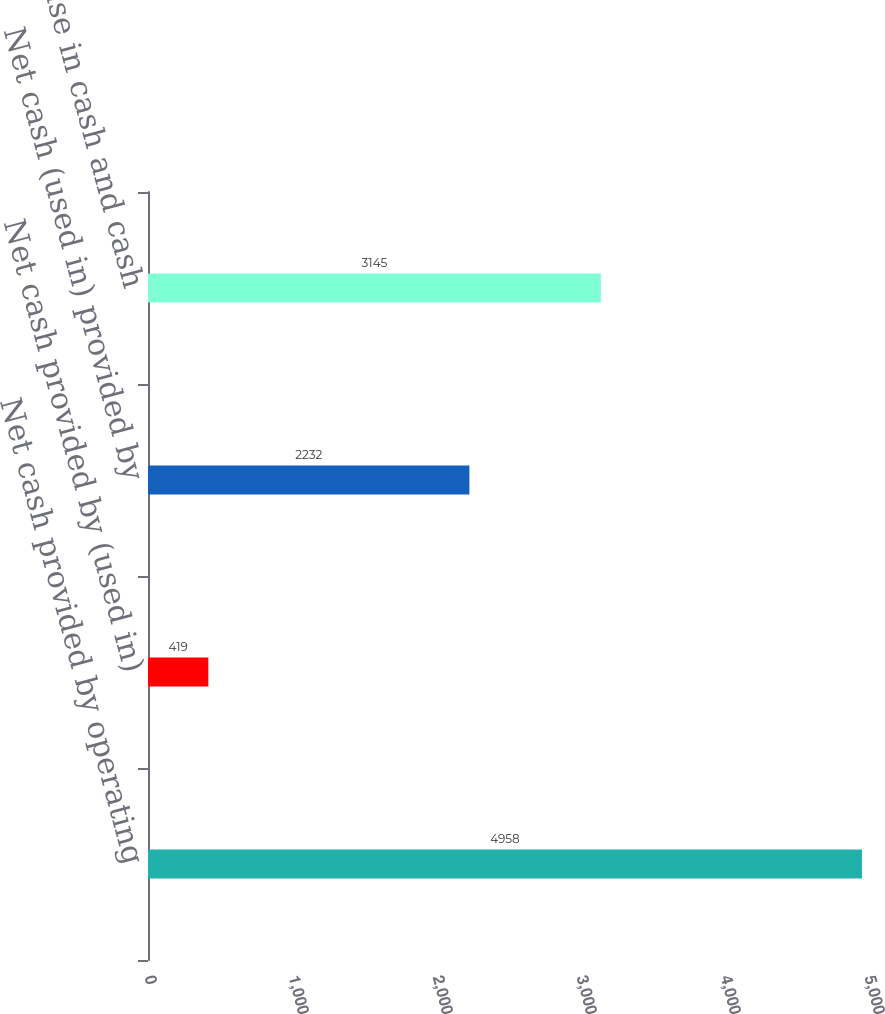Convert chart to OTSL. <chart><loc_0><loc_0><loc_500><loc_500><bar_chart><fcel>Net cash provided by operating<fcel>Net cash provided by (used in)<fcel>Net cash (used in) provided by<fcel>Net increase in cash and cash<nl><fcel>4958<fcel>419<fcel>2232<fcel>3145<nl></chart> 